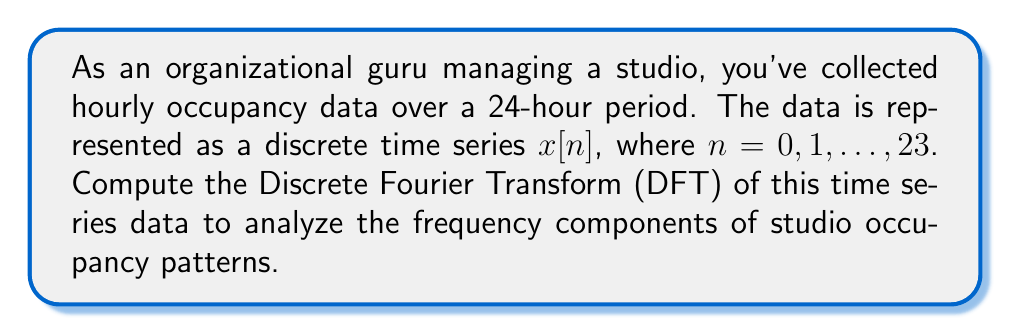Can you solve this math problem? To compute the Discrete Fourier Transform (DFT) of the studio occupancy time series, we'll follow these steps:

1) The DFT formula for a discrete time series $x[n]$ of length $N$ is:

   $$X[k] = \sum_{n=0}^{N-1} x[n] e^{-i2\pi kn/N}$$

   where $k = 0, 1, ..., N-1$

2) In this case, $N = 24$ (24-hour period)

3) We need to calculate $X[k]$ for each $k$ from 0 to 23:

   $$X[k] = \sum_{n=0}^{23} x[n] e^{-i2\pi kn/24}$$

4) This calculation involves complex exponentials and can be decomposed into real and imaginary parts:

   $$X[k] = \sum_{n=0}^{23} x[n] (\cos(2\pi kn/24) - i \sin(2\pi kn/24))$$

5) The result will be a series of complex numbers $X[k]$, where:
   - $|X[k]|$ represents the magnitude of the $k$-th frequency component
   - $\arg(X[k])$ represents the phase of the $k$-th frequency component

6) Interpreting the results:
   - $X[0]$ represents the DC component (average occupancy)
   - $X[1]$ to $X[11]$ represent increasing frequency components
   - $X[12]$ represents the highest frequency component (Nyquist frequency)
   - $X[13]$ to $X[23]$ are complex conjugates of $X[11]$ to $X[1]$

7) The dominant frequency components will have larger magnitudes, indicating periodic patterns in studio occupancy.
Answer: $X[k] = \sum_{n=0}^{23} x[n] e^{-i2\pi kn/24}$, $k = 0, 1, ..., 23$ 